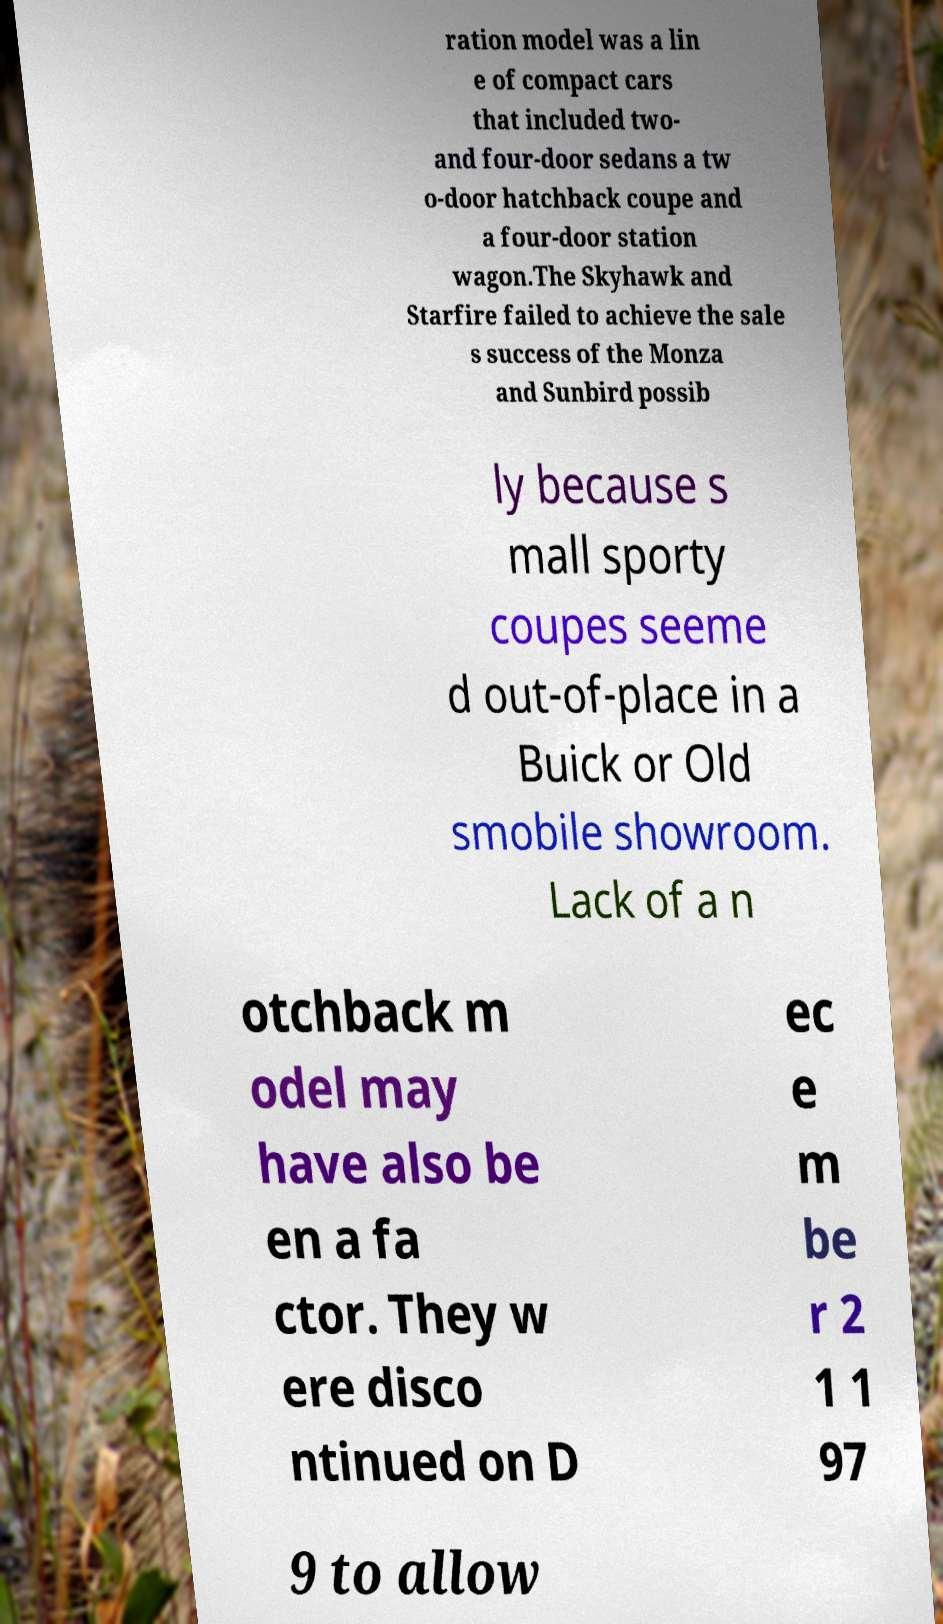Please identify and transcribe the text found in this image. ration model was a lin e of compact cars that included two- and four-door sedans a tw o-door hatchback coupe and a four-door station wagon.The Skyhawk and Starfire failed to achieve the sale s success of the Monza and Sunbird possib ly because s mall sporty coupes seeme d out-of-place in a Buick or Old smobile showroom. Lack of a n otchback m odel may have also be en a fa ctor. They w ere disco ntinued on D ec e m be r 2 1 1 97 9 to allow 